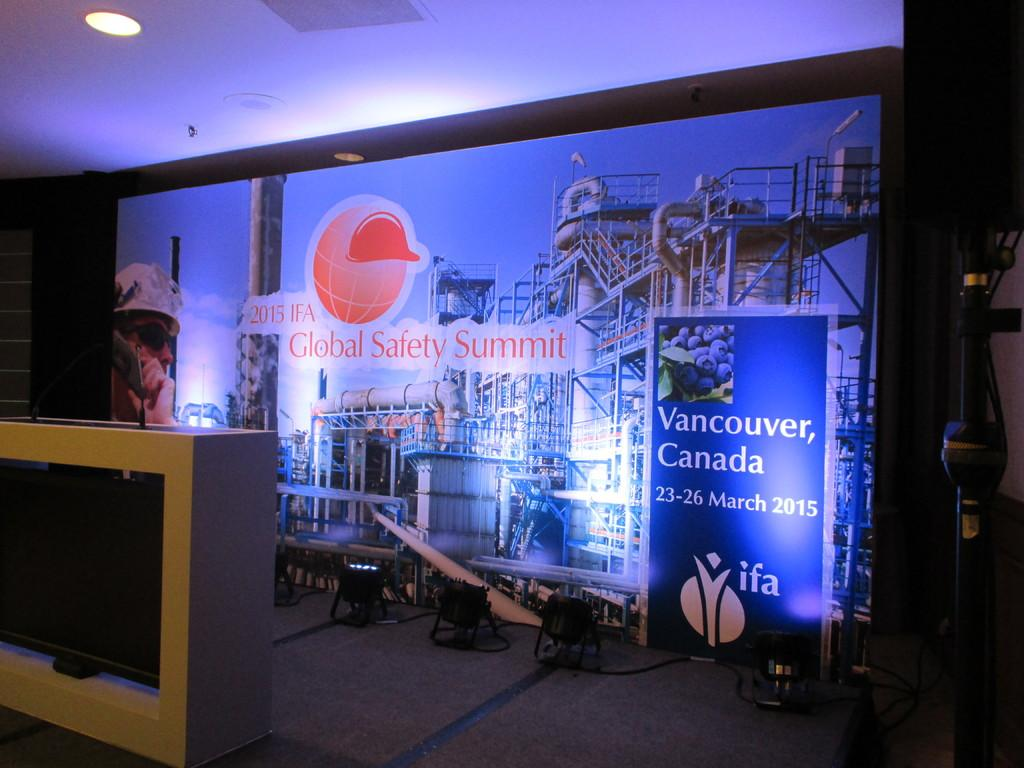<image>
Summarize the visual content of the image. The stage for the 2015 Global Safety Summit in Canada 